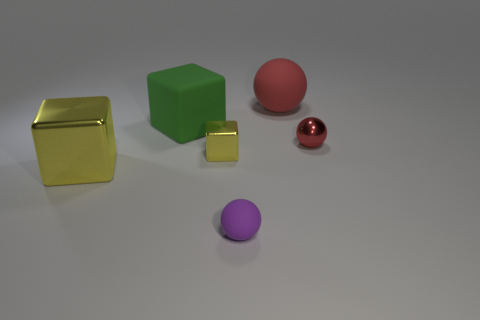What is the size of the other purple ball that is the same material as the large sphere?
Your answer should be very brief. Small. What number of other large red rubber things have the same shape as the big red object?
Provide a succinct answer. 0. Are the purple thing and the red object right of the red rubber sphere made of the same material?
Offer a terse response. No. Are there more small objects that are in front of the purple thing than blue metallic balls?
Your answer should be very brief. No. There is a small object that is the same color as the large matte ball; what shape is it?
Your response must be concise. Sphere. Are there any green things made of the same material as the purple ball?
Provide a short and direct response. Yes. Do the tiny ball in front of the red shiny ball and the tiny ball right of the small purple object have the same material?
Offer a terse response. No. Are there the same number of large metallic objects that are on the right side of the red rubber thing and big things that are right of the big yellow metal block?
Provide a short and direct response. No. The other ball that is the same size as the purple ball is what color?
Ensure brevity in your answer.  Red. Is there a block of the same color as the small metal sphere?
Give a very brief answer. No. 